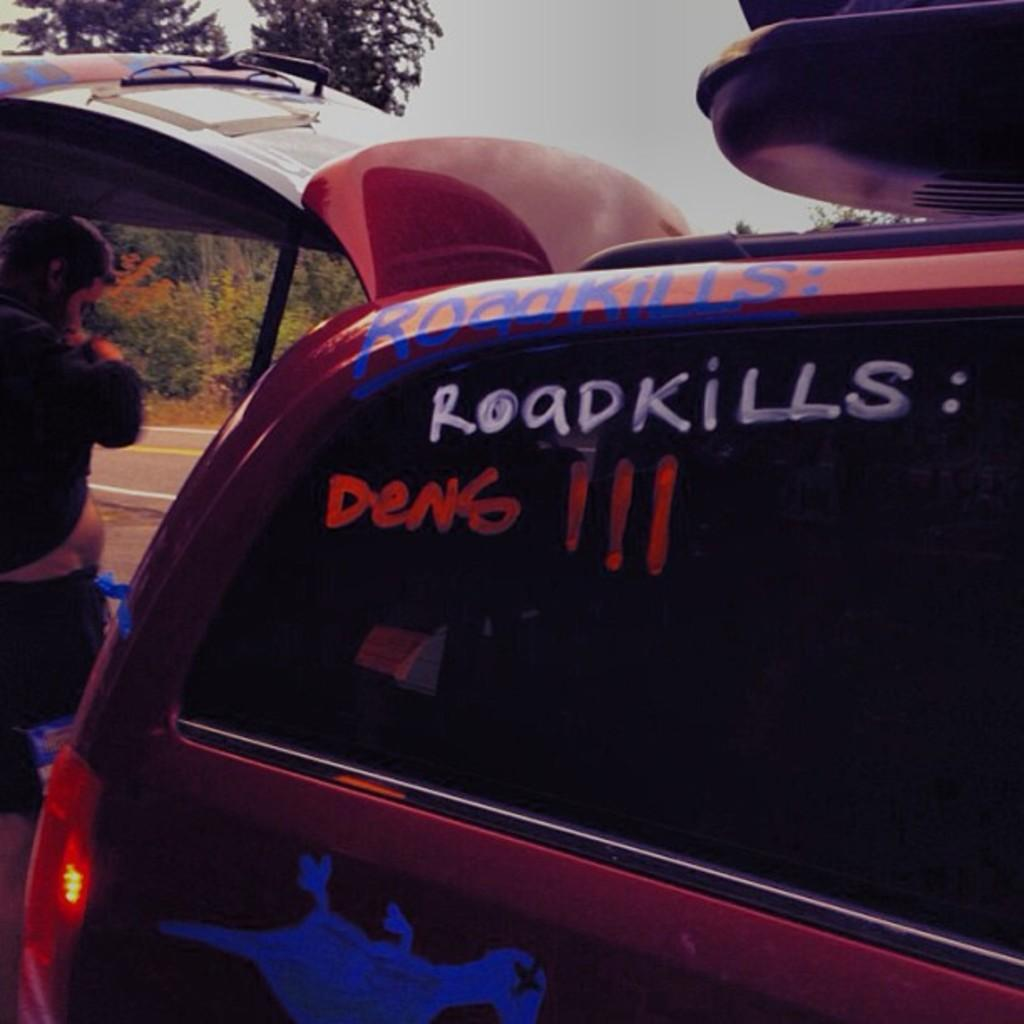What is the main subject in the foreground of the image? There is a vehicle in the foreground of the image. Can you describe the person on the left side of the image? There is a man standing on the left side of the image. What can be seen in the background of the image? There are trees and the sky visible in the background of the image. What song is the man singing in the image? There is no indication in the image that the man is singing, so it cannot be determined from the picture. 